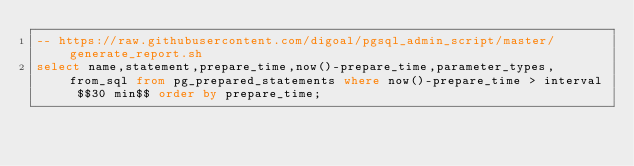<code> <loc_0><loc_0><loc_500><loc_500><_SQL_>-- https://raw.githubusercontent.com/digoal/pgsql_admin_script/master/generate_report.sh
select name,statement,prepare_time,now()-prepare_time,parameter_types,from_sql from pg_prepared_statements where now()-prepare_time > interval $$30 min$$ order by prepare_time;
</code> 